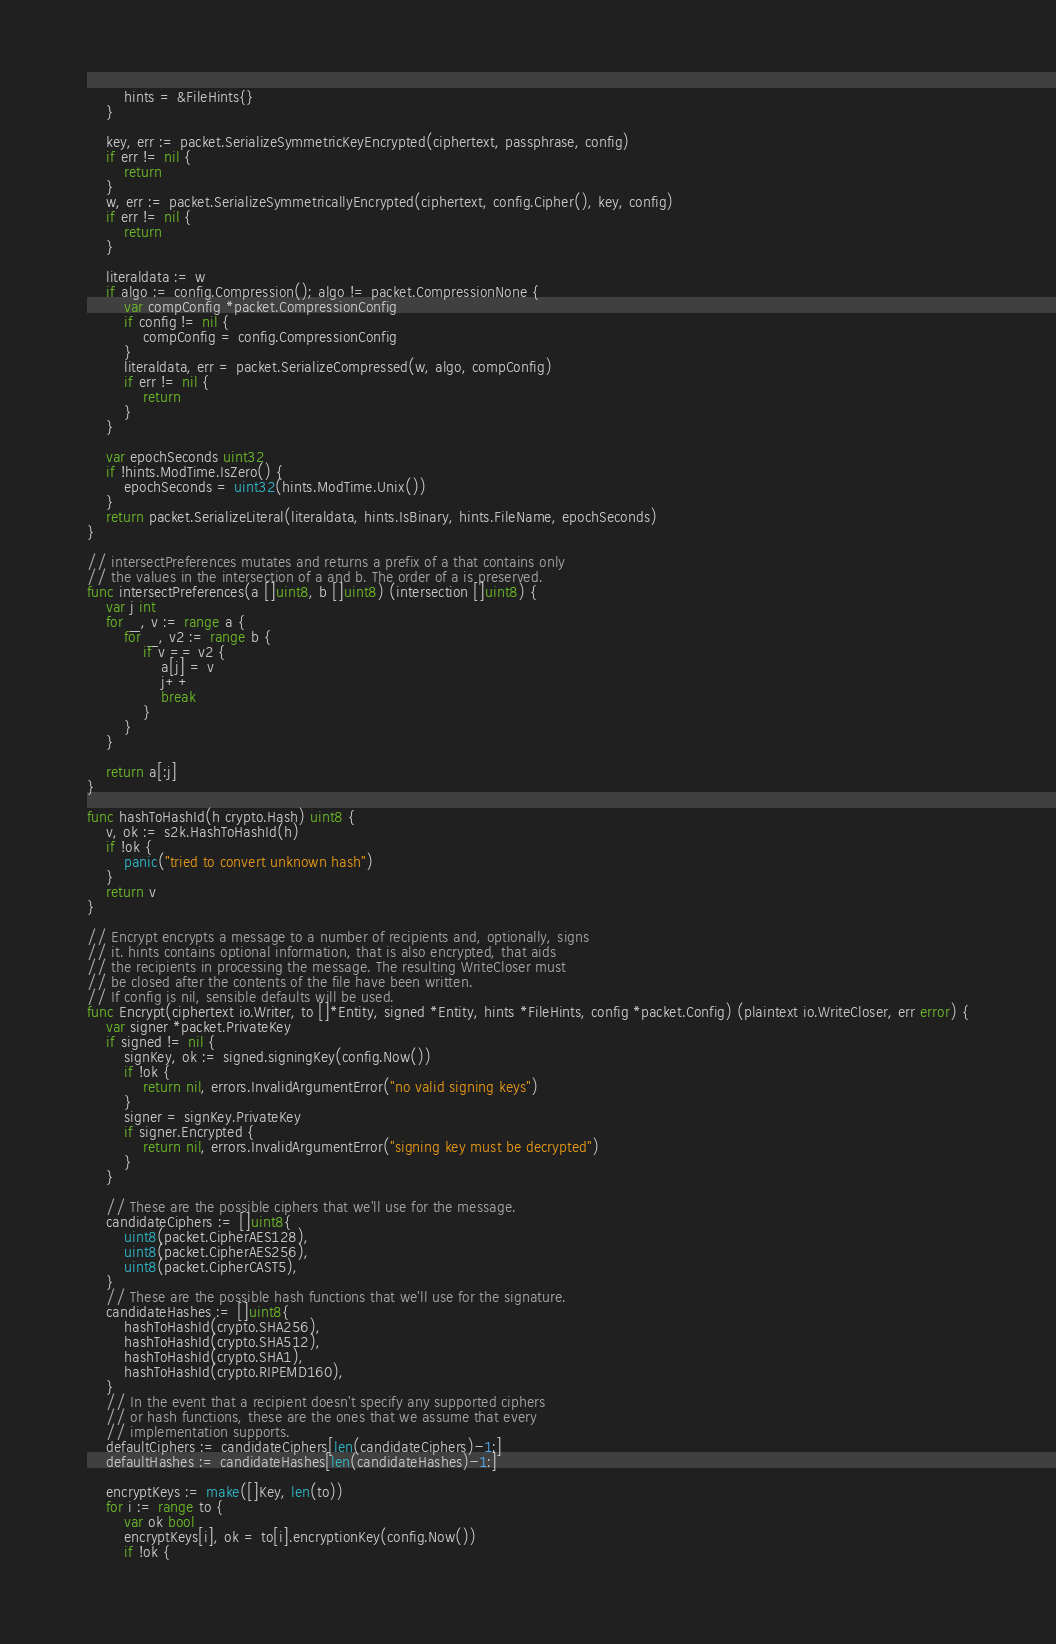Convert code to text. <code><loc_0><loc_0><loc_500><loc_500><_Go_>		hints = &FileHints{}
	}

	key, err := packet.SerializeSymmetricKeyEncrypted(ciphertext, passphrase, config)
	if err != nil {
		return
	}
	w, err := packet.SerializeSymmetricallyEncrypted(ciphertext, config.Cipher(), key, config)
	if err != nil {
		return
	}

	literaldata := w
	if algo := config.Compression(); algo != packet.CompressionNone {
		var compConfig *packet.CompressionConfig
		if config != nil {
			compConfig = config.CompressionConfig
		}
		literaldata, err = packet.SerializeCompressed(w, algo, compConfig)
		if err != nil {
			return
		}
	}

	var epochSeconds uint32
	if !hints.ModTime.IsZero() {
		epochSeconds = uint32(hints.ModTime.Unix())
	}
	return packet.SerializeLiteral(literaldata, hints.IsBinary, hints.FileName, epochSeconds)
}

// intersectPreferences mutates and returns a prefix of a that contains only
// the values in the intersection of a and b. The order of a is preserved.
func intersectPreferences(a []uint8, b []uint8) (intersection []uint8) {
	var j int
	for _, v := range a {
		for _, v2 := range b {
			if v == v2 {
				a[j] = v
				j++
				break
			}
		}
	}

	return a[:j]
}

func hashToHashId(h crypto.Hash) uint8 {
	v, ok := s2k.HashToHashId(h)
	if !ok {
		panic("tried to convert unknown hash")
	}
	return v
}

// Encrypt encrypts a message to a number of recipients and, optionally, signs
// it. hints contains optional information, that is also encrypted, that aids
// the recipients in processing the message. The resulting WriteCloser must
// be closed after the contents of the file have been written.
// If config is nil, sensible defaults will be used.
func Encrypt(ciphertext io.Writer, to []*Entity, signed *Entity, hints *FileHints, config *packet.Config) (plaintext io.WriteCloser, err error) {
	var signer *packet.PrivateKey
	if signed != nil {
		signKey, ok := signed.signingKey(config.Now())
		if !ok {
			return nil, errors.InvalidArgumentError("no valid signing keys")
		}
		signer = signKey.PrivateKey
		if signer.Encrypted {
			return nil, errors.InvalidArgumentError("signing key must be decrypted")
		}
	}

	// These are the possible ciphers that we'll use for the message.
	candidateCiphers := []uint8{
		uint8(packet.CipherAES128),
		uint8(packet.CipherAES256),
		uint8(packet.CipherCAST5),
	}
	// These are the possible hash functions that we'll use for the signature.
	candidateHashes := []uint8{
		hashToHashId(crypto.SHA256),
		hashToHashId(crypto.SHA512),
		hashToHashId(crypto.SHA1),
		hashToHashId(crypto.RIPEMD160),
	}
	// In the event that a recipient doesn't specify any supported ciphers
	// or hash functions, these are the ones that we assume that every
	// implementation supports.
	defaultCiphers := candidateCiphers[len(candidateCiphers)-1:]
	defaultHashes := candidateHashes[len(candidateHashes)-1:]

	encryptKeys := make([]Key, len(to))
	for i := range to {
		var ok bool
		encryptKeys[i], ok = to[i].encryptionKey(config.Now())
		if !ok {</code> 